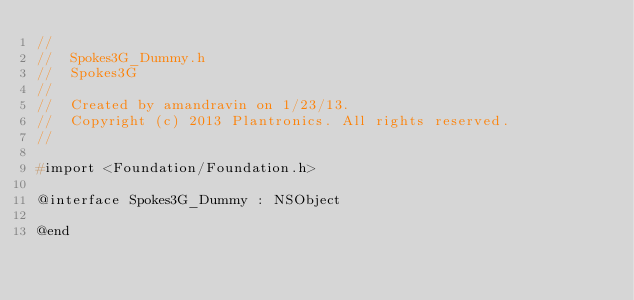<code> <loc_0><loc_0><loc_500><loc_500><_C_>//
//  Spokes3G_Dummy.h
//  Spokes3G
//
//  Created by amandravin on 1/23/13.
//  Copyright (c) 2013 Plantronics. All rights reserved.
//

#import <Foundation/Foundation.h>

@interface Spokes3G_Dummy : NSObject

@end
</code> 